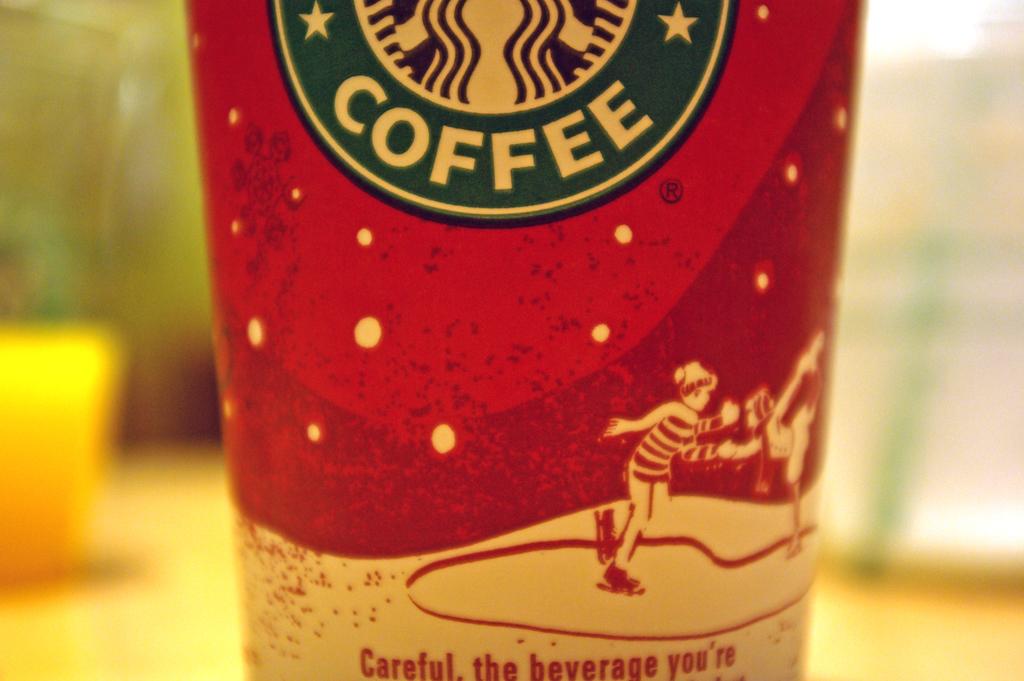What kind of drink is this?
Your answer should be very brief. Coffee. 